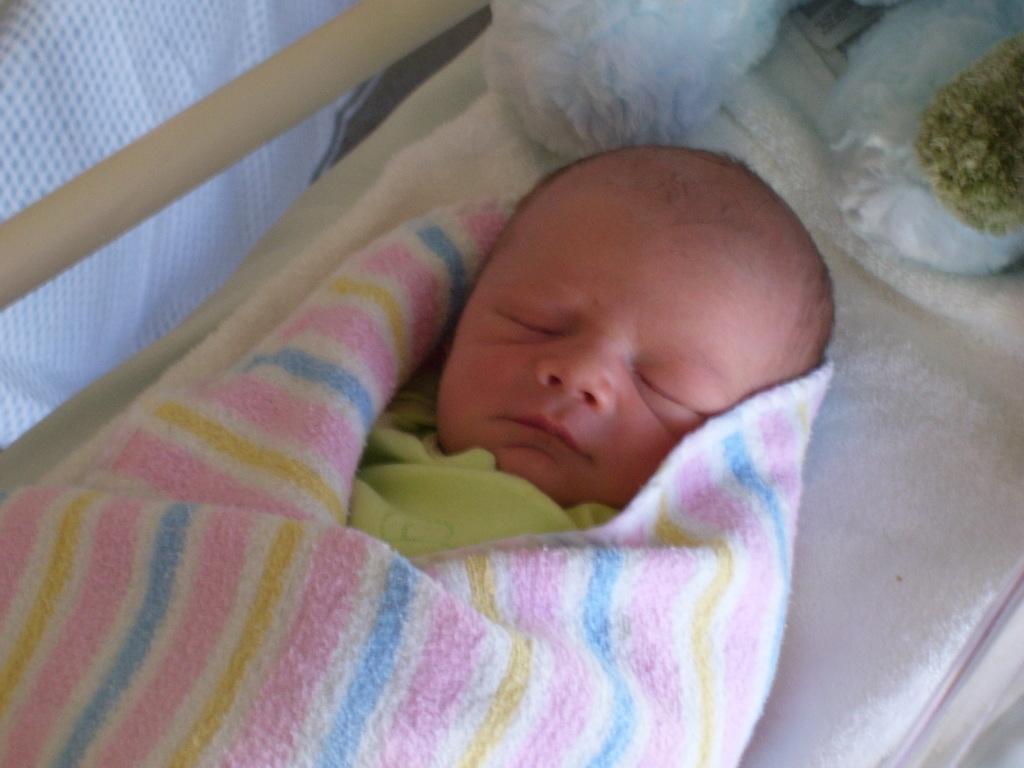Can you describe this image briefly? In this image we can see a baby sleeping on the bed, there are two objects at the top of the image, there is a blanket around the baby. 